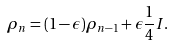Convert formula to latex. <formula><loc_0><loc_0><loc_500><loc_500>\rho _ { n } = ( 1 - \epsilon ) \rho _ { n - 1 } + \epsilon \frac { 1 } { 4 } I .</formula> 